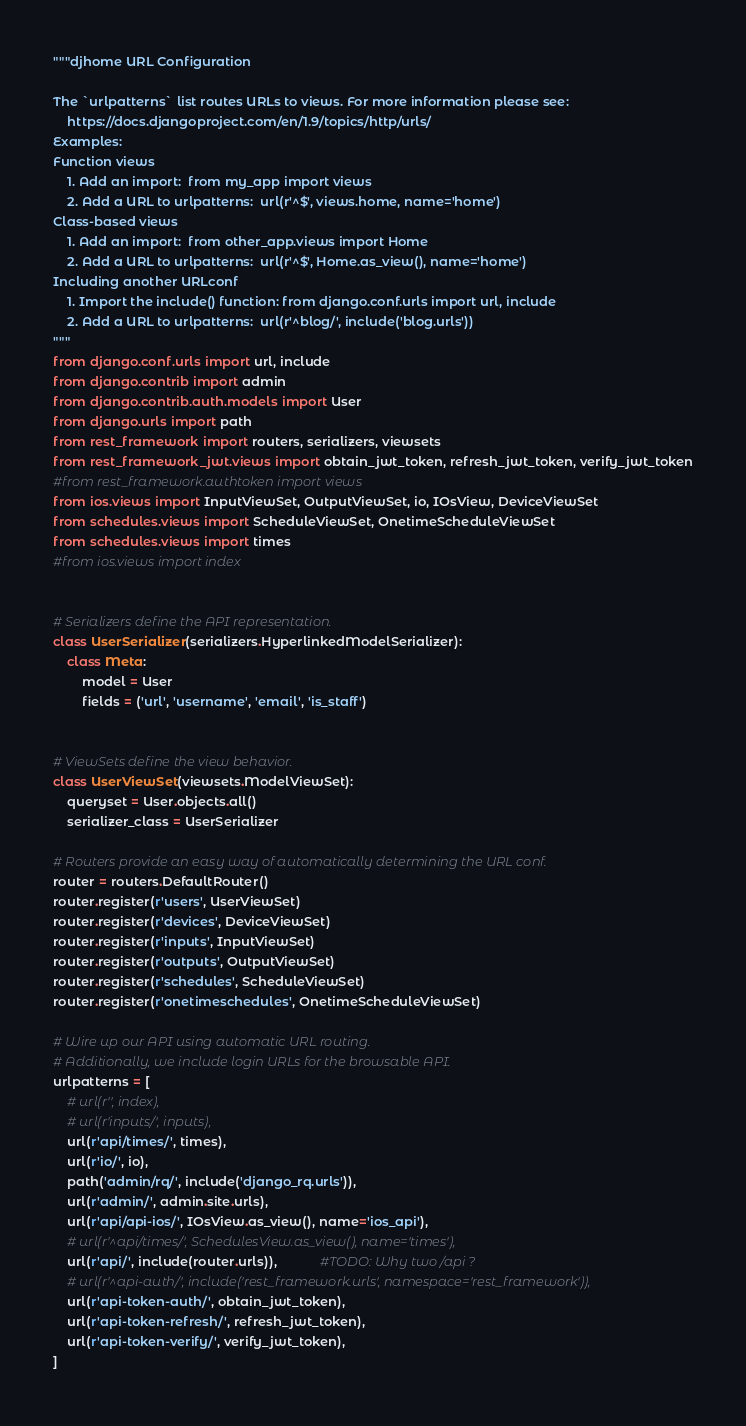Convert code to text. <code><loc_0><loc_0><loc_500><loc_500><_Python_>"""djhome URL Configuration

The `urlpatterns` list routes URLs to views. For more information please see:
    https://docs.djangoproject.com/en/1.9/topics/http/urls/
Examples:
Function views
    1. Add an import:  from my_app import views
    2. Add a URL to urlpatterns:  url(r'^$', views.home, name='home')
Class-based views
    1. Add an import:  from other_app.views import Home
    2. Add a URL to urlpatterns:  url(r'^$', Home.as_view(), name='home')
Including another URLconf
    1. Import the include() function: from django.conf.urls import url, include
    2. Add a URL to urlpatterns:  url(r'^blog/', include('blog.urls'))
"""
from django.conf.urls import url, include
from django.contrib import admin
from django.contrib.auth.models import User
from django.urls import path
from rest_framework import routers, serializers, viewsets
from rest_framework_jwt.views import obtain_jwt_token, refresh_jwt_token, verify_jwt_token
#from rest_framework.authtoken import views
from ios.views import InputViewSet, OutputViewSet, io, IOsView, DeviceViewSet
from schedules.views import ScheduleViewSet, OnetimeScheduleViewSet
from schedules.views import times
#from ios.views import index


# Serializers define the API representation.
class UserSerializer(serializers.HyperlinkedModelSerializer):
    class Meta:
        model = User
        fields = ('url', 'username', 'email', 'is_staff')


# ViewSets define the view behavior.
class UserViewSet(viewsets.ModelViewSet):
    queryset = User.objects.all()
    serializer_class = UserSerializer

# Routers provide an easy way of automatically determining the URL conf.
router = routers.DefaultRouter()
router.register(r'users', UserViewSet)
router.register(r'devices', DeviceViewSet)
router.register(r'inputs', InputViewSet)
router.register(r'outputs', OutputViewSet)
router.register(r'schedules', ScheduleViewSet)
router.register(r'onetimeschedules', OnetimeScheduleViewSet)

# Wire up our API using automatic URL routing.
# Additionally, we include login URLs for the browsable API.
urlpatterns = [
    # url(r'', index),
    # url(r'inputs/', inputs),
    url(r'api/times/', times),
    url(r'io/', io),
    path('admin/rq/', include('django_rq.urls')),
    url(r'admin/', admin.site.urls),
    url(r'api/api-ios/', IOsView.as_view(), name='ios_api'),
    # url(r'^api/times/', SchedulesView.as_view(), name='times'),
    url(r'api/', include(router.urls)),            #TODO: Why two /api ?
    # url(r'^api-auth/', include('rest_framework.urls', namespace='rest_framework')),
    url(r'api-token-auth/', obtain_jwt_token),
    url(r'api-token-refresh/', refresh_jwt_token),
    url(r'api-token-verify/', verify_jwt_token),
]
</code> 